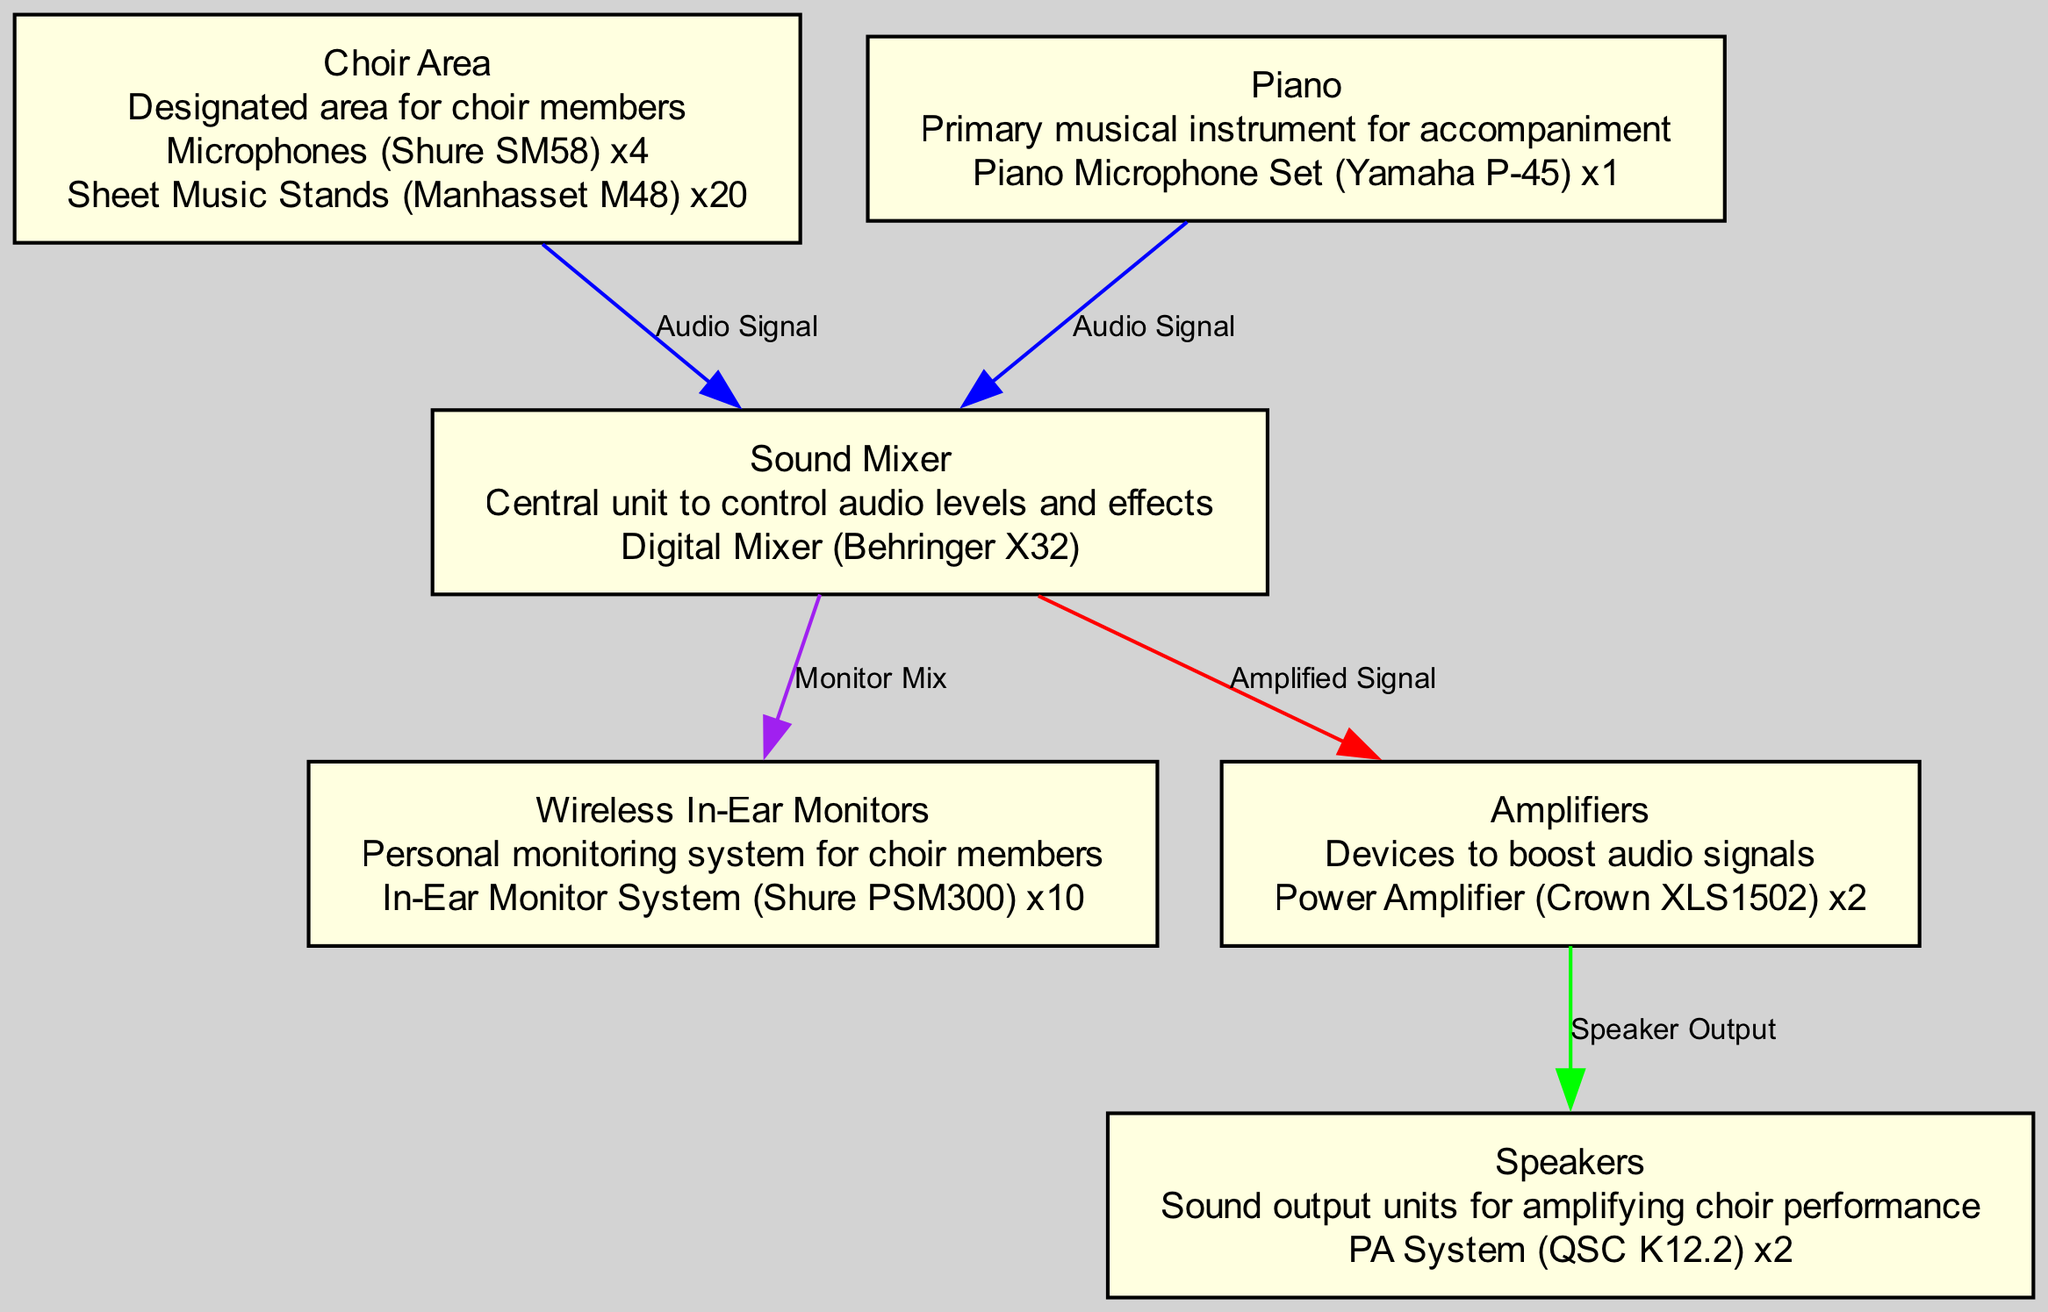What is the type of microphones used in the Choir Area? The diagram details that four condenser microphones, specifically the Shure SM58 model, are listed under the Choir Area.
Answer: Condenser How many speakers are included in the layout? The diagram shows that there are two active speakers of the model QSC K12.2 listed under the Speakers section.
Answer: 2 What is the primary musical instrument for accompaniment? The diagram clearly states that the piano is the primary musical instrument, indicated in the Piano section.
Answer: Piano Which section connects to the Sound Mixer with an audio signal? The diagram specifies that both the Choir Area and the Piano connect to the Sound Mixer using an audio signal, indicated by the edges drawn from those nodes to the Sound Mixer.
Answer: Choir Area and Piano How many wireless in-ear monitor systems are provided for choir members? The layout indicates under Wireless In-Ear Monitors that there are ten in-ear monitor systems of the model Shure PSM300, denoting the number available for use.
Answer: 10 What is the connection type between the Sound Mixer and Amplifiers? The diagram shows that the type of connection from the Sound Mixer to the Amplifiers is an amplified signal, represented by a colored edge leading from the Sound Mixer to the Amplifiers node.
Answer: Amplified Signal What equipment is located at the back stage center? The diagram denotes that the Sound Mixer, specifically labeled with the digital mixer Behringer X32, is located at the back stage center.
Answer: Sound Mixer Which devices are used for personal monitoring by choir members? The Wireless In-Ear Monitors section indicates that the personal monitor systems used are of the model Shure PSM300, which is designed for monitoring by choir members.
Answer: In-Ear Monitor System What type of amplifier is utilized and how many are there? The diagram indicates that there are two Crown XLS1502 power amplifiers listed under the Amplifiers section.
Answer: Power Amplifier, 2 